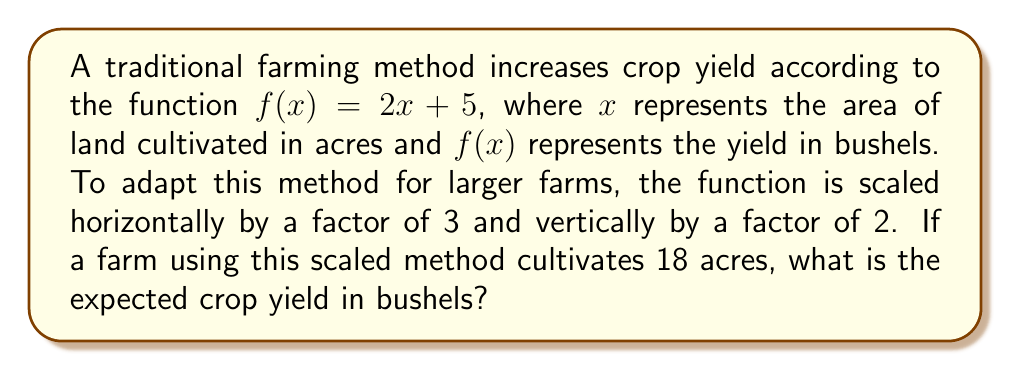Can you solve this math problem? 1. The original function is $f(x) = 2x + 5$

2. Scaling horizontally by a factor of 3:
   Replace $x$ with $\frac{x}{3}$
   $f(\frac{x}{3}) = 2(\frac{x}{3}) + 5$

3. Scaling vertically by a factor of 2:
   Multiply the entire function by 2
   $2f(\frac{x}{3}) = 2[2(\frac{x}{3}) + 5]$

4. Simplify the scaled function:
   $g(x) = 2[2(\frac{x}{3}) + 5]$
   $g(x) = 2[\frac{2x}{3} + 5]$
   $g(x) = \frac{4x}{3} + 10$

5. Calculate the yield for 18 acres:
   $g(18) = \frac{4(18)}{3} + 10$
   $g(18) = 24 + 10 = 34$

Therefore, the expected crop yield for 18 acres using the scaled traditional farming method is 34 bushels.
Answer: 34 bushels 